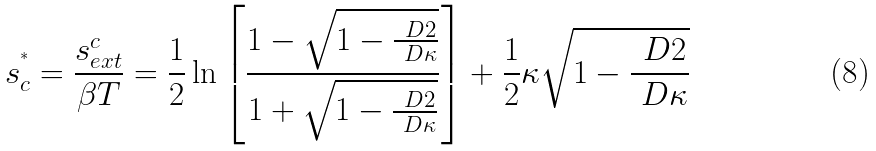Convert formula to latex. <formula><loc_0><loc_0><loc_500><loc_500>s ^ { ^ { * } } _ { c } = \frac { s _ { e x t } ^ { c } } { \beta T } = \frac { 1 } { 2 } \ln \left [ \frac { 1 - \sqrt { 1 - \frac { \ D 2 } { \ D \kappa } } } { 1 + \sqrt { 1 - \frac { \ D 2 } { \ D \kappa } } } \right ] + \frac { 1 } { 2 } \kappa \sqrt { 1 - \frac { \ D 2 } { \ D \kappa } }</formula> 